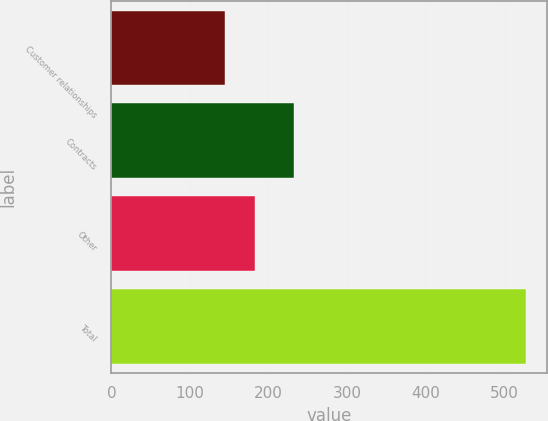Convert chart. <chart><loc_0><loc_0><loc_500><loc_500><bar_chart><fcel>Customer relationships<fcel>Contracts<fcel>Other<fcel>Total<nl><fcel>145<fcel>233<fcel>183.3<fcel>528<nl></chart> 